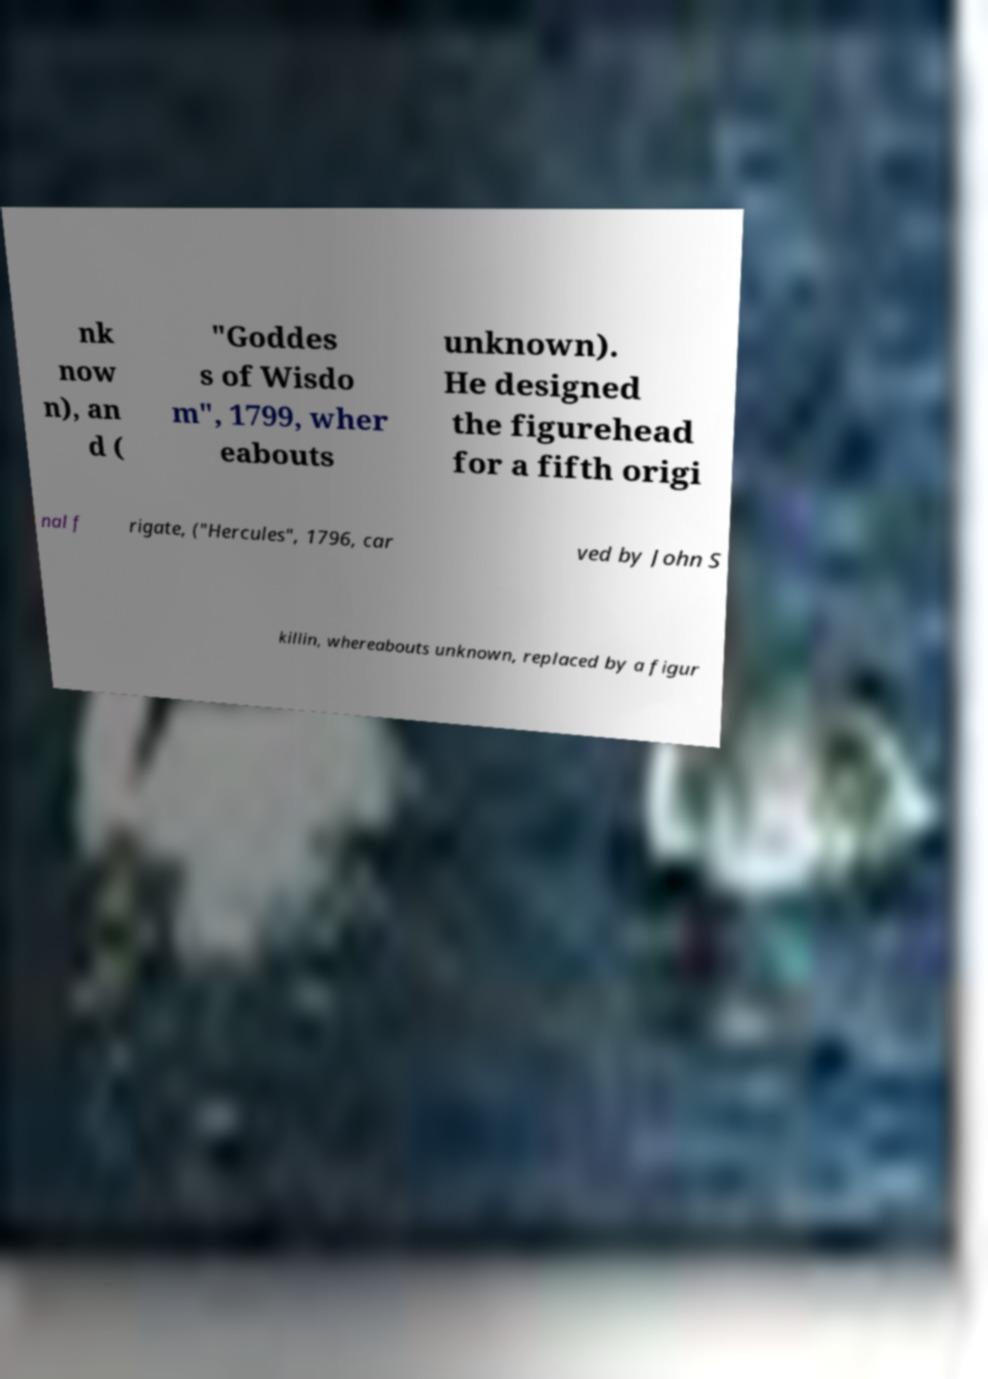Can you read and provide the text displayed in the image?This photo seems to have some interesting text. Can you extract and type it out for me? nk now n), an d ( "Goddes s of Wisdo m", 1799, wher eabouts unknown). He designed the figurehead for a fifth origi nal f rigate, ("Hercules", 1796, car ved by John S killin, whereabouts unknown, replaced by a figur 